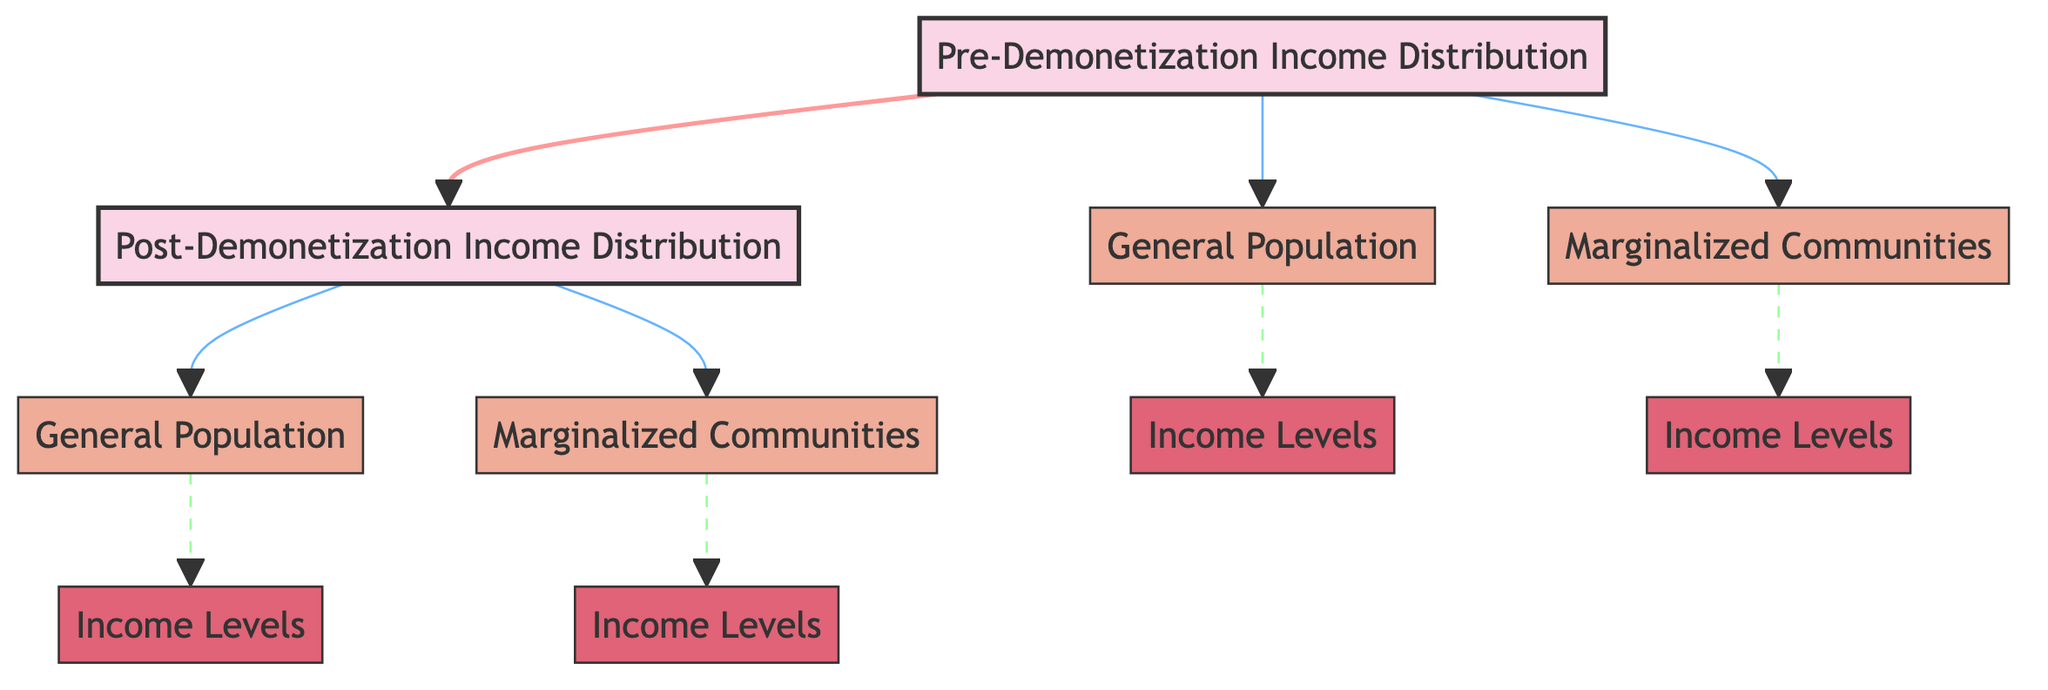What are the two main categories shown in the diagram? The diagram has two main categories represented by the nodes labeled "Pre-Demonetization Income Distribution" and "Post-Demonetization Income Distribution." These are the top-level nodes.
Answer: Pre-Demonetization Income Distribution, Post-Demonetization Income Distribution How many entities are linked to the pre-demonetization income distribution? The pre-demonetization node is linked to two entities: "General Population" and "Marginalized Communities." Counting these connections gives us the answer.
Answer: 2 What does the dashed line signify in the diagram? The dashed lines denote a different relationship, specifically representing a less direct or more complex relationship compared to solid lines. They link the "Post-Demonetization Income Distribution" to its entities.
Answer: Less direct relationship Which income distribution shows more entities linked to it? By comparing the two main nodes, "Pre-Demonetization Income Distribution" has two linked entities and "Post-Demonetization Income Distribution" also has two, indicating they are equal in the number of linked entities.
Answer: Equal What is the relationship between "General Population" and "Income Levels" before demonetization? "General Population" links to "Income Levels" and based on the diagram representation, this shows that there is a direct connection from the general populace to the income levels recorded before demonetization.
Answer: Direct connection How does the income distribution change post-demonetization for marginalized communities? To answer this, we observe that "Marginalized Communities" connects to "Income Levels" after demonetization. Thus, the change indicates a transition or impact on their income levels compared to pre-demonetization.
Answer: Transition in income levels Which category has a focus on marginalized communities after demonetization? The node labeled "Marginalized Communities" connects to the "Post-Demonetization Income Distribution," specifically indicating its focus on this demographic after the transition.
Answer: Marginalized Communities What is the visual style difference between links to marginalized communities and general population? The links to marginalized communities are represented with dashed lines, while links to the general population are solid lines, indicating a difference in the nature of these relationships.
Answer: Dashed lines for marginalized communities How many total income level nodes are represented in the diagram? There are four nodes labeled "Income Levels" connected to both the general and marginalized communities, two for each income distribution category, totaling to four.
Answer: 4 